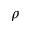Convert formula to latex. <formula><loc_0><loc_0><loc_500><loc_500>\rho</formula> 